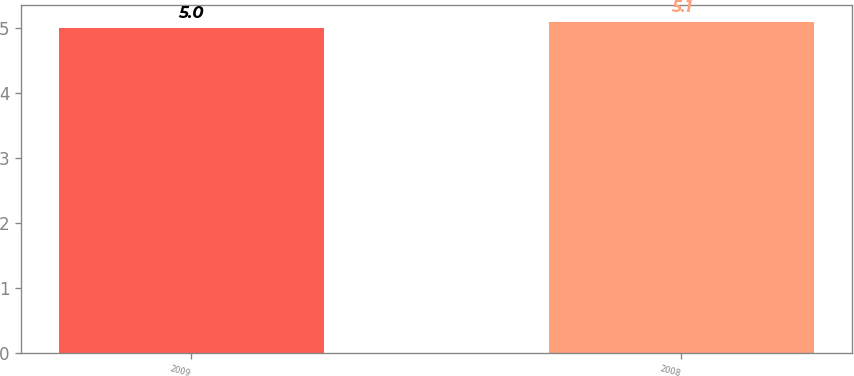Convert chart. <chart><loc_0><loc_0><loc_500><loc_500><bar_chart><fcel>2009<fcel>2008<nl><fcel>5<fcel>5.1<nl></chart> 